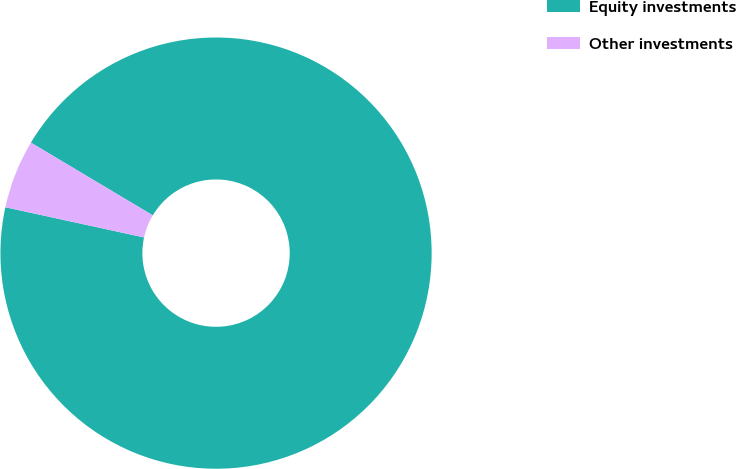Convert chart to OTSL. <chart><loc_0><loc_0><loc_500><loc_500><pie_chart><fcel>Equity investments<fcel>Other investments<nl><fcel>94.85%<fcel>5.15%<nl></chart> 